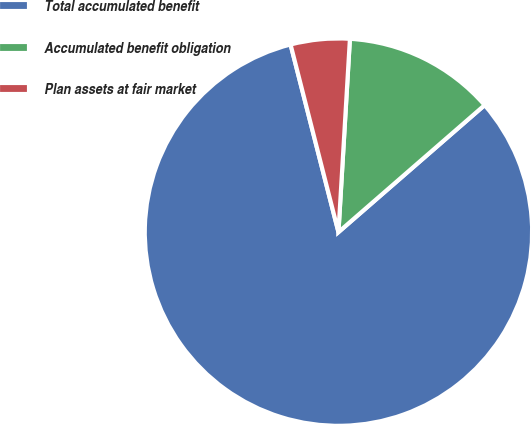<chart> <loc_0><loc_0><loc_500><loc_500><pie_chart><fcel>Total accumulated benefit<fcel>Accumulated benefit obligation<fcel>Plan assets at fair market<nl><fcel>82.4%<fcel>12.67%<fcel>4.92%<nl></chart> 